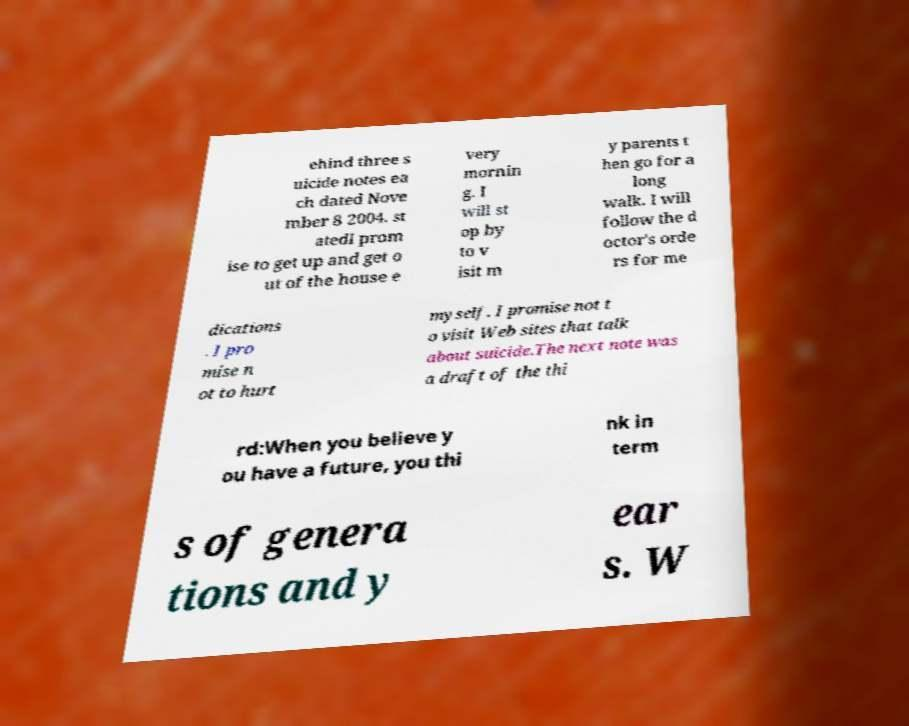What messages or text are displayed in this image? I need them in a readable, typed format. ehind three s uicide notes ea ch dated Nove mber 8 2004. st atedI prom ise to get up and get o ut of the house e very mornin g. I will st op by to v isit m y parents t hen go for a long walk. I will follow the d octor's orde rs for me dications . I pro mise n ot to hurt myself. I promise not t o visit Web sites that talk about suicide.The next note was a draft of the thi rd:When you believe y ou have a future, you thi nk in term s of genera tions and y ear s. W 